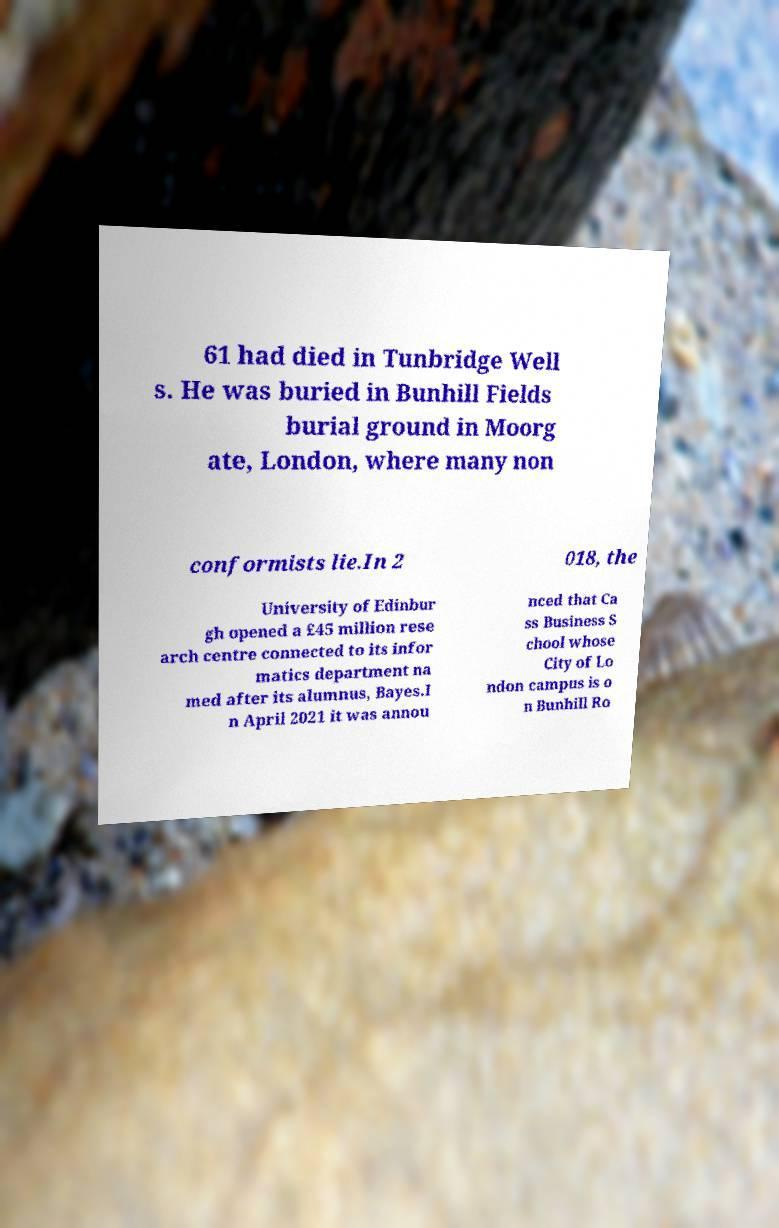Could you extract and type out the text from this image? 61 had died in Tunbridge Well s. He was buried in Bunhill Fields burial ground in Moorg ate, London, where many non conformists lie.In 2 018, the University of Edinbur gh opened a £45 million rese arch centre connected to its infor matics department na med after its alumnus, Bayes.I n April 2021 it was annou nced that Ca ss Business S chool whose City of Lo ndon campus is o n Bunhill Ro 